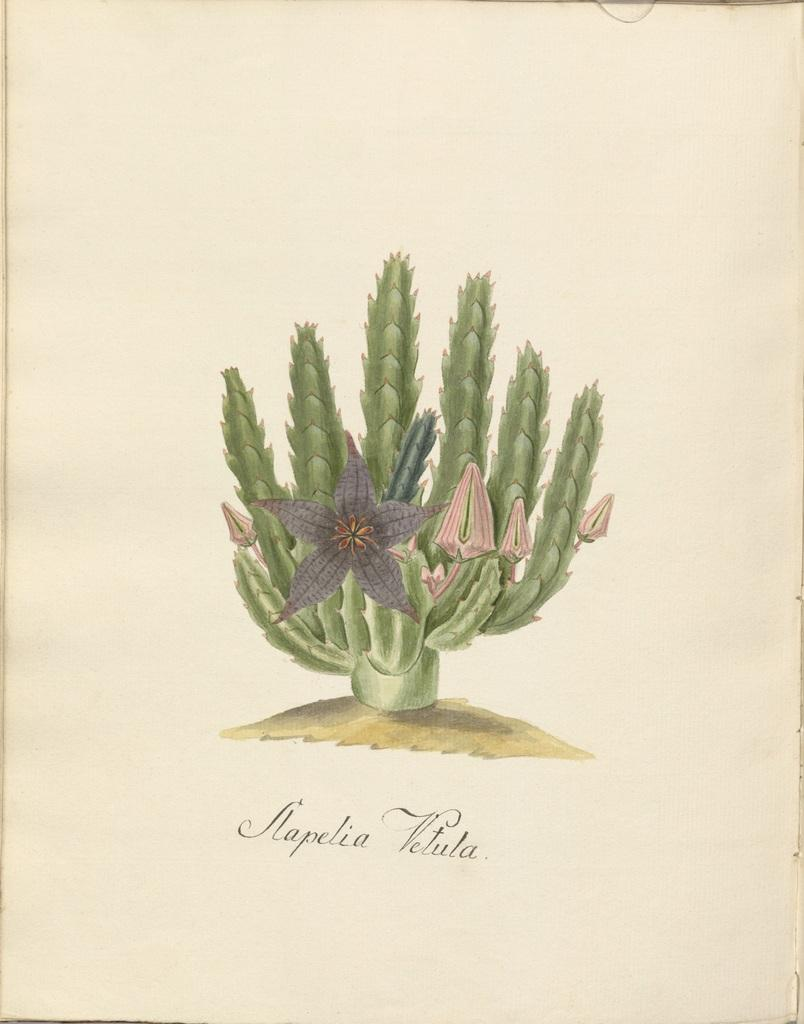What is the main subject of the image? There is a depiction of a plant in the image. Can you describe any additional features of the image? There is text written on the bottom side of the image. What type of guitar can be seen in the image? There is no guitar present in the image; it features a depiction of a plant and text. Can you tell me how many pairs of shoes are visible in the image? There are no shoes present in the image. 